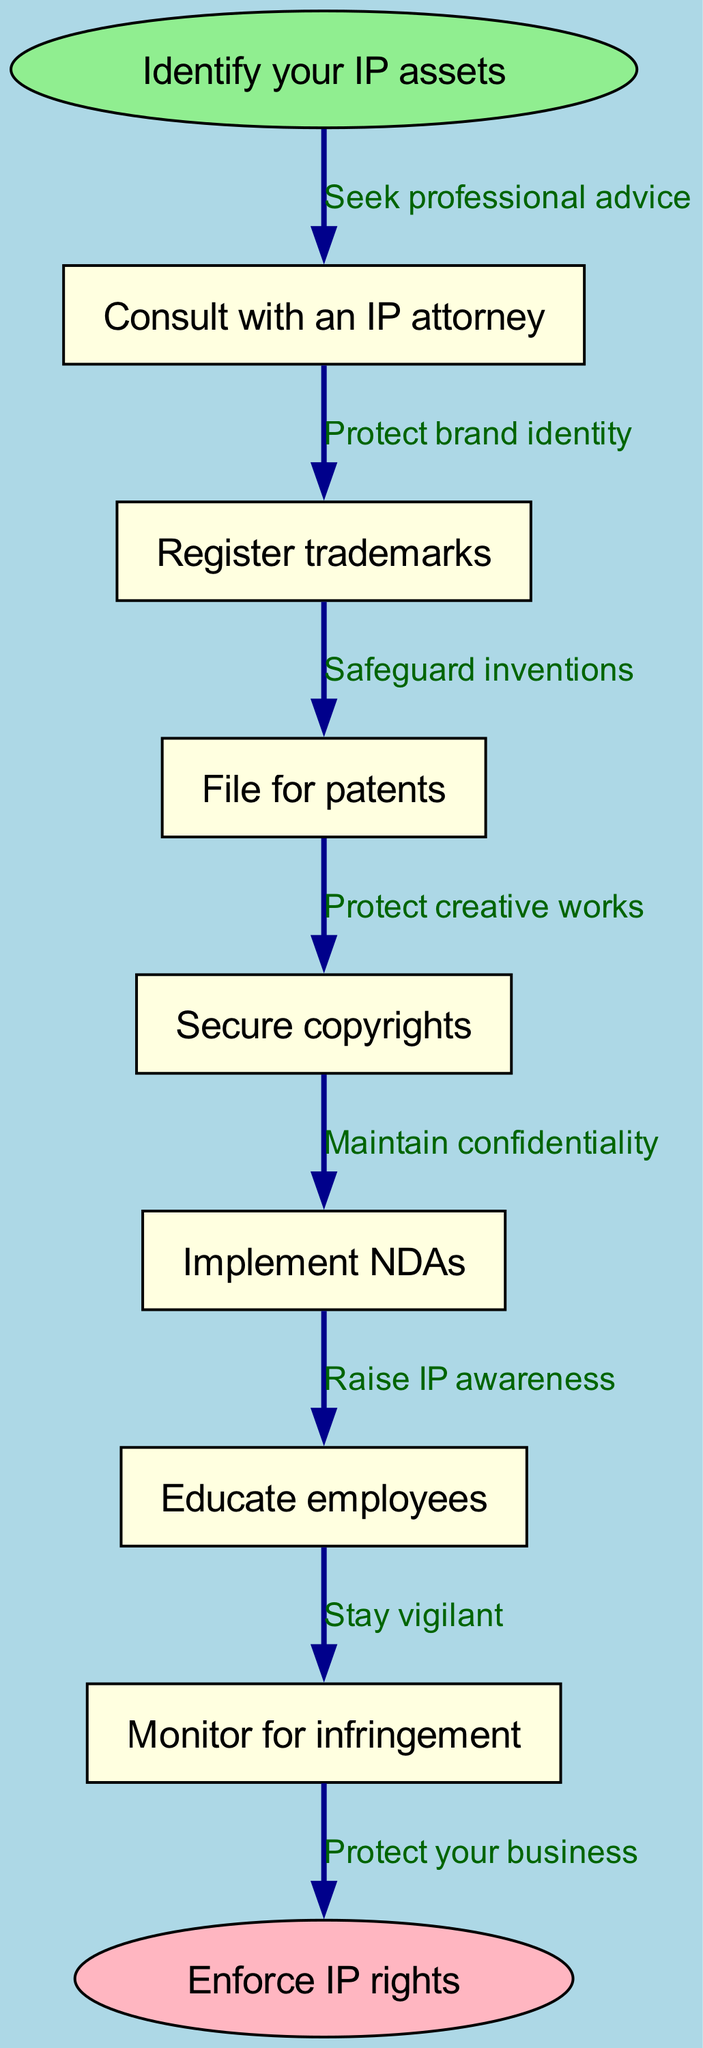What is the starting point of the flow chart? The starting point of the flow chart is indicated as the first node labeled "Identify your IP assets." This is where the process begins before moving on to subsequent steps.
Answer: Identify your IP assets How many steps are there in the flow chart? The flow chart has six steps outlined before reaching the end node. Counting the listed steps will confirm this total.
Answer: 6 What is the end node labeled in the diagram? The end node, which signifies the conclusion of the flow, is labeled "Enforce IP rights." This distinctly marks the final outcome of the instructional process.
Answer: Enforce IP rights What step follows "Consult with an IP attorney"? The next step, which immediately follows "Consult with an IP attorney," is "Register trademarks." This indicates a progression in the protective measures taken for intellectual property.
Answer: Register trademarks Which step is focused on maintaining confidentiality? The step that emphasizes maintaining confidentiality is labeled "Implement NDAs." This highlights a critical part of safeguarding intellectual property by ensuring privacy in sensitive information.
Answer: Implement NDAs What is the edge description from "File for patents"? The edge description from "File for patents" is "Safeguard inventions." This indicates the purpose of taking that specific action in the process of protecting intellectual property.
Answer: Safeguard inventions Which step indicates a need for vigilance against IP infringement? The step that indicates a need for vigilance against IP infringement is "Monitor for infringement." This highlights the necessity to actively watch for any violations of intellectual property rights.
Answer: Monitor for infringement What action follows after securing copyrights? After "Secure copyrights," the next action is "Implement NDAs." This shows the continuation of protective measures after ensuring copyright protection.
Answer: Implement NDAs What action is recommended after the step "Educate employees"? Following the step "Educate employees," the next action recommended is "Monitor for infringement." This suggests a proactive approach even after raising awareness among personnel.
Answer: Monitor for infringement 